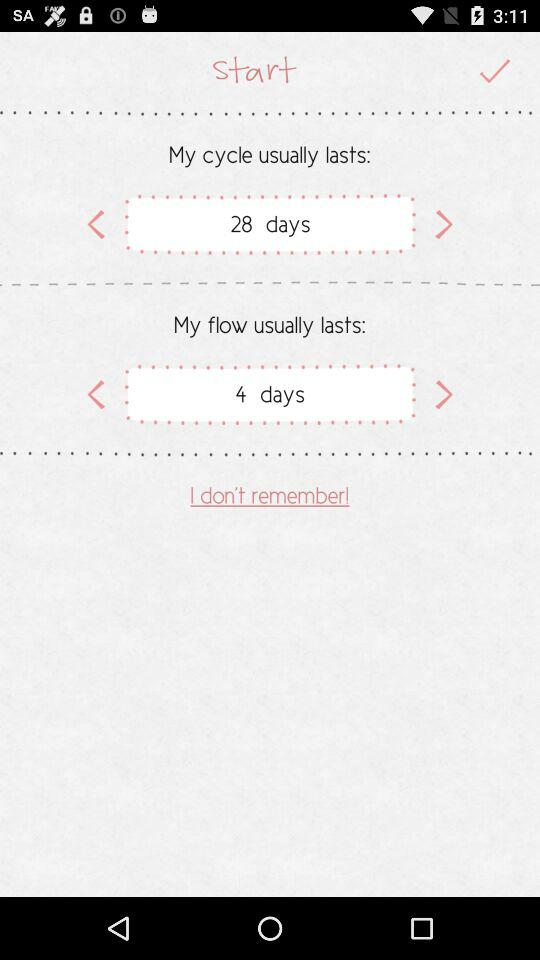How long does the flow usually last? The flow usually lasts for 4 days. 